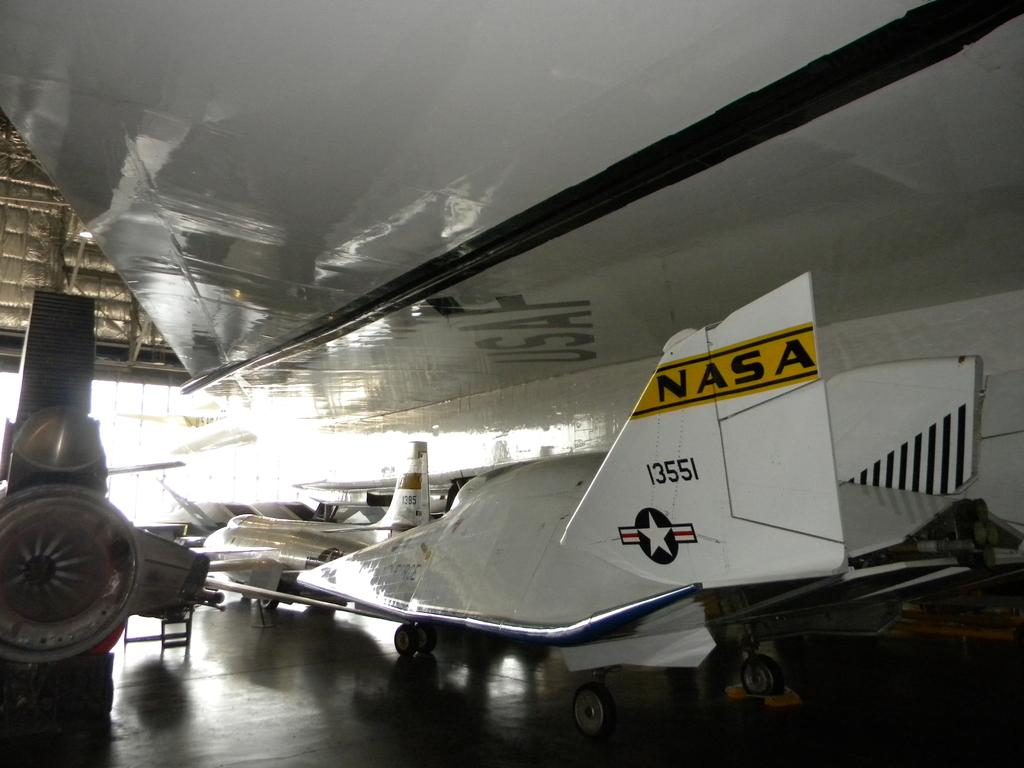<image>
Present a compact description of the photo's key features. A NASA plane is in a hanger with the numbers 13551 on the tail. 